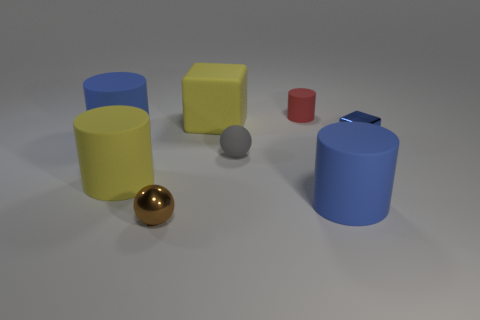Add 2 large metallic blocks. How many objects exist? 10 Subtract all small rubber cylinders. How many cylinders are left? 3 Subtract all yellow balls. How many blue cylinders are left? 2 Subtract all brown balls. How many balls are left? 1 Subtract 1 cubes. How many cubes are left? 1 Add 6 brown metal things. How many brown metal things exist? 7 Subtract 0 cyan balls. How many objects are left? 8 Subtract all spheres. How many objects are left? 6 Subtract all purple cylinders. Subtract all gray cubes. How many cylinders are left? 4 Subtract all large blue cylinders. Subtract all brown things. How many objects are left? 5 